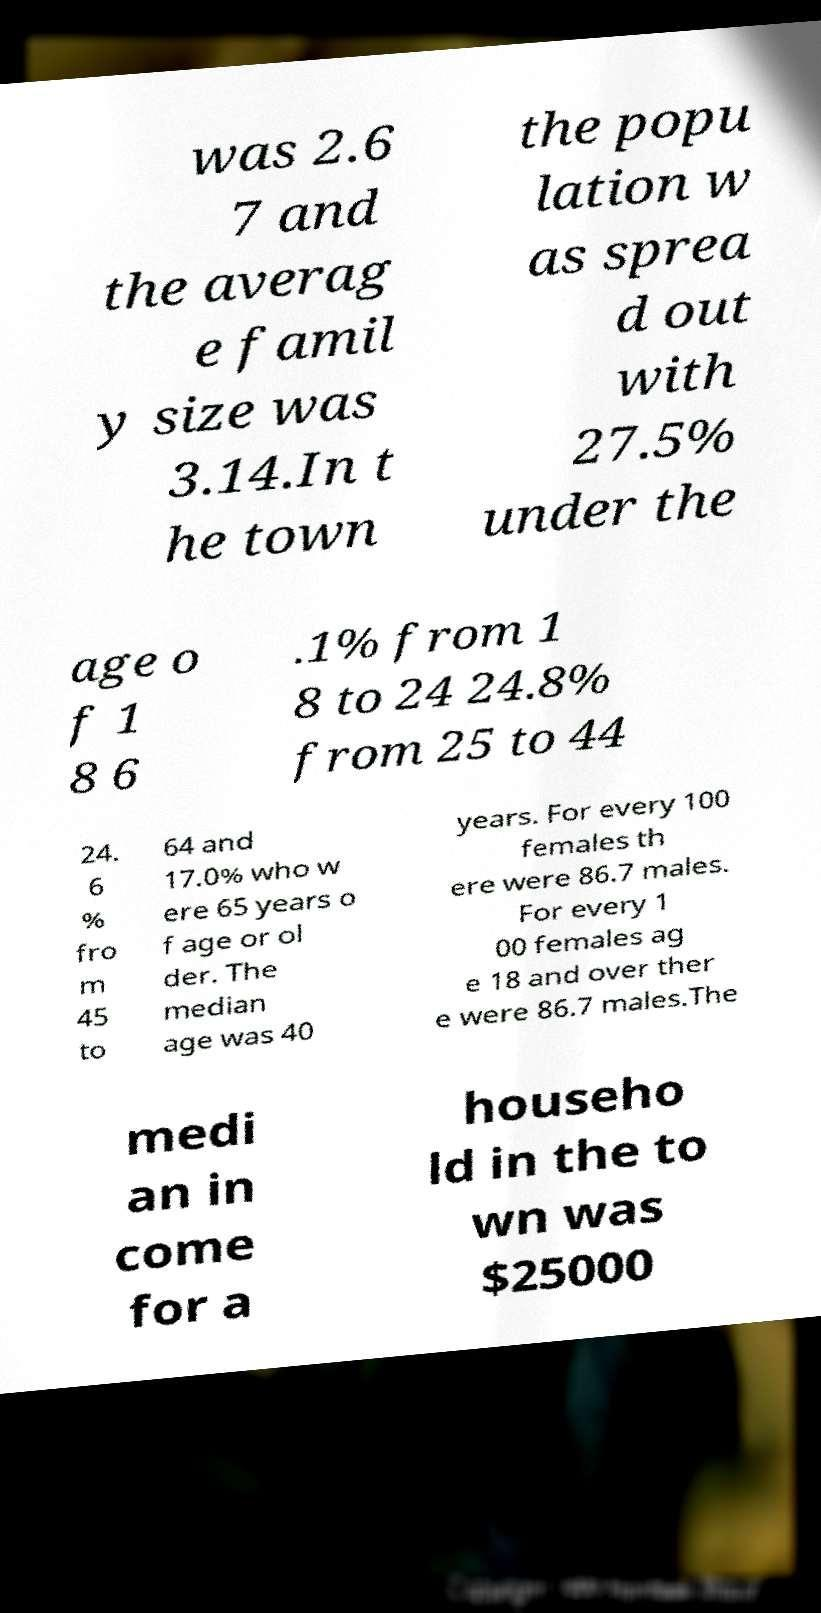There's text embedded in this image that I need extracted. Can you transcribe it verbatim? was 2.6 7 and the averag e famil y size was 3.14.In t he town the popu lation w as sprea d out with 27.5% under the age o f 1 8 6 .1% from 1 8 to 24 24.8% from 25 to 44 24. 6 % fro m 45 to 64 and 17.0% who w ere 65 years o f age or ol der. The median age was 40 years. For every 100 females th ere were 86.7 males. For every 1 00 females ag e 18 and over ther e were 86.7 males.The medi an in come for a househo ld in the to wn was $25000 